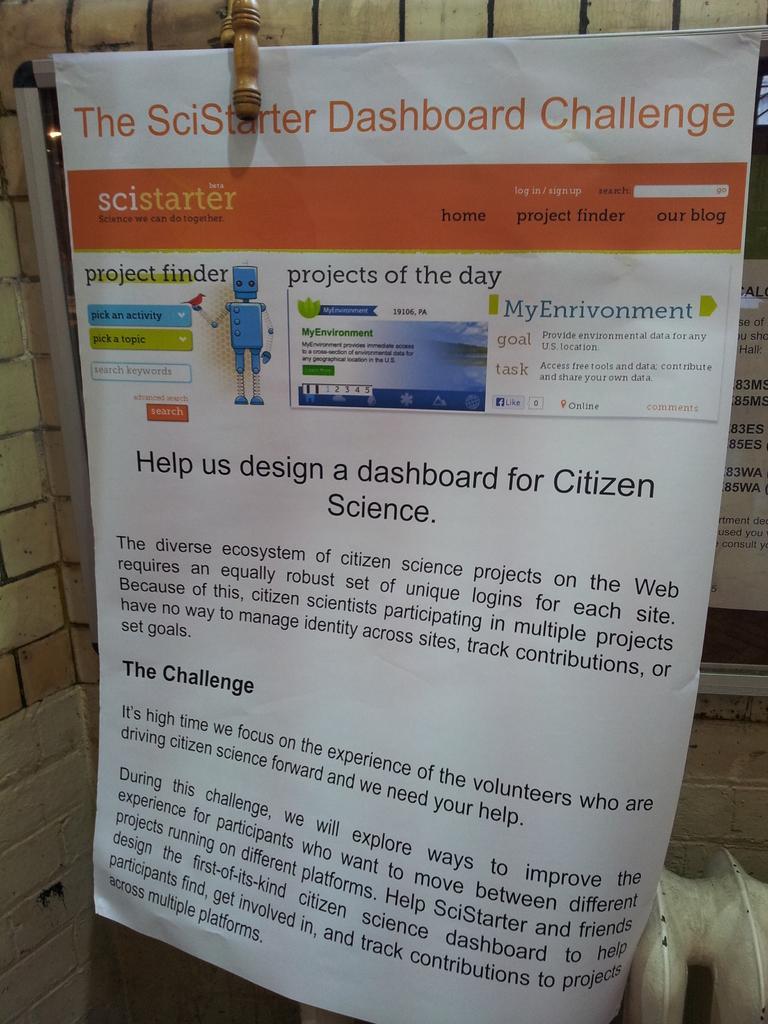Describe this image in one or two sentences. In this picture, we see a poster or a banner in white color with some text written on it. Behind that, we see a board with some text written on it. In the background, we see a wall. In the right bottom, we see something in white color with some text written on it. 